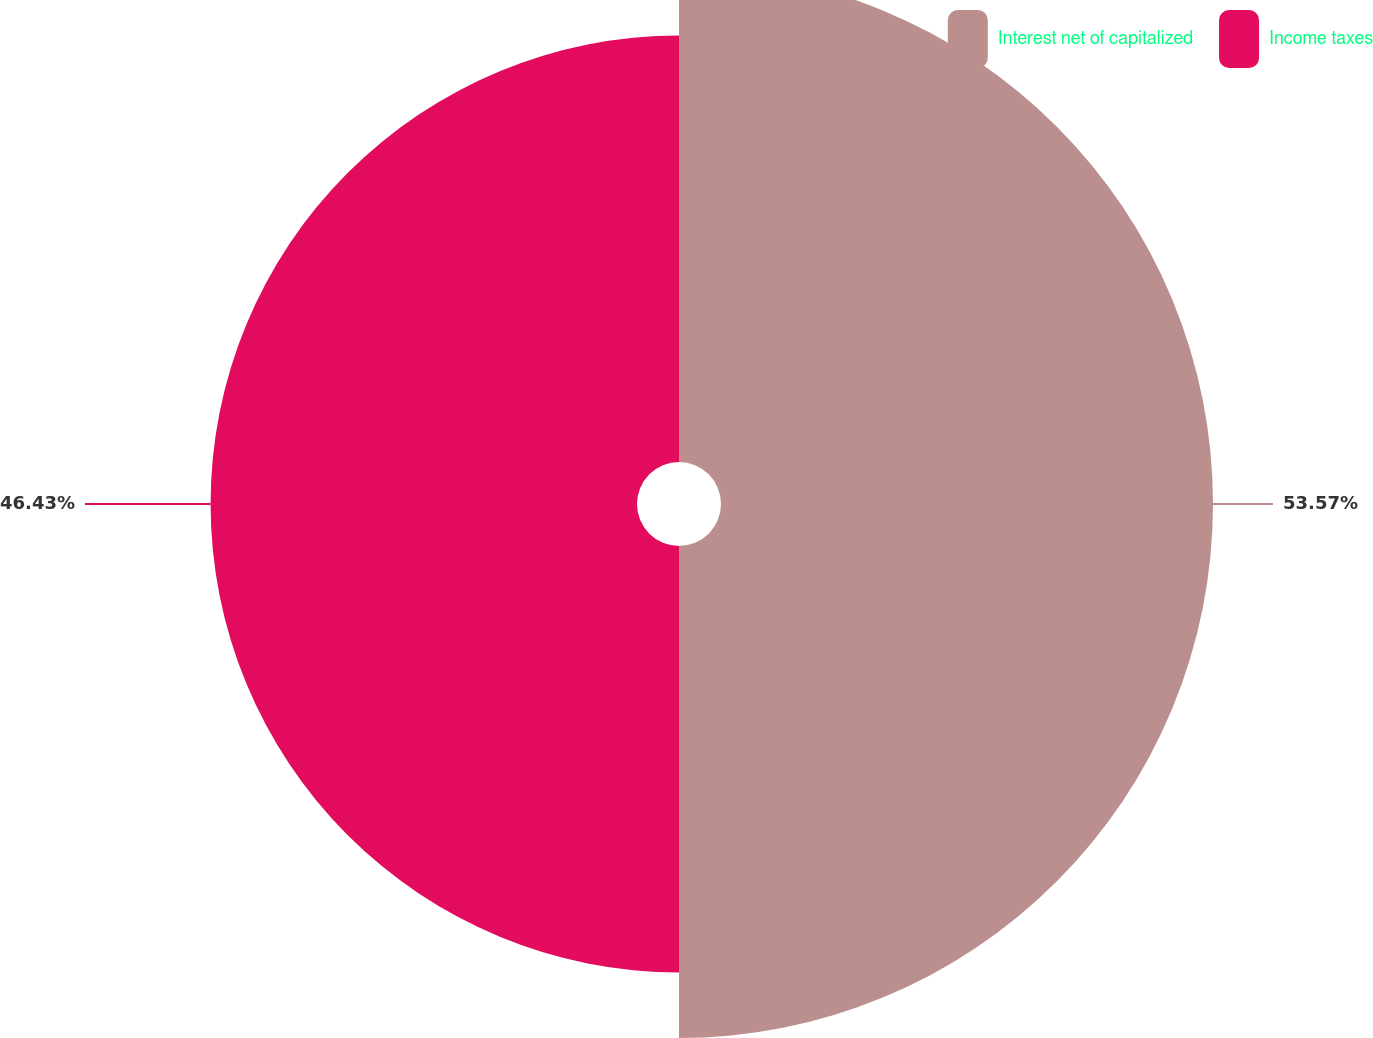Convert chart. <chart><loc_0><loc_0><loc_500><loc_500><pie_chart><fcel>Interest net of capitalized<fcel>Income taxes<nl><fcel>53.57%<fcel>46.43%<nl></chart> 